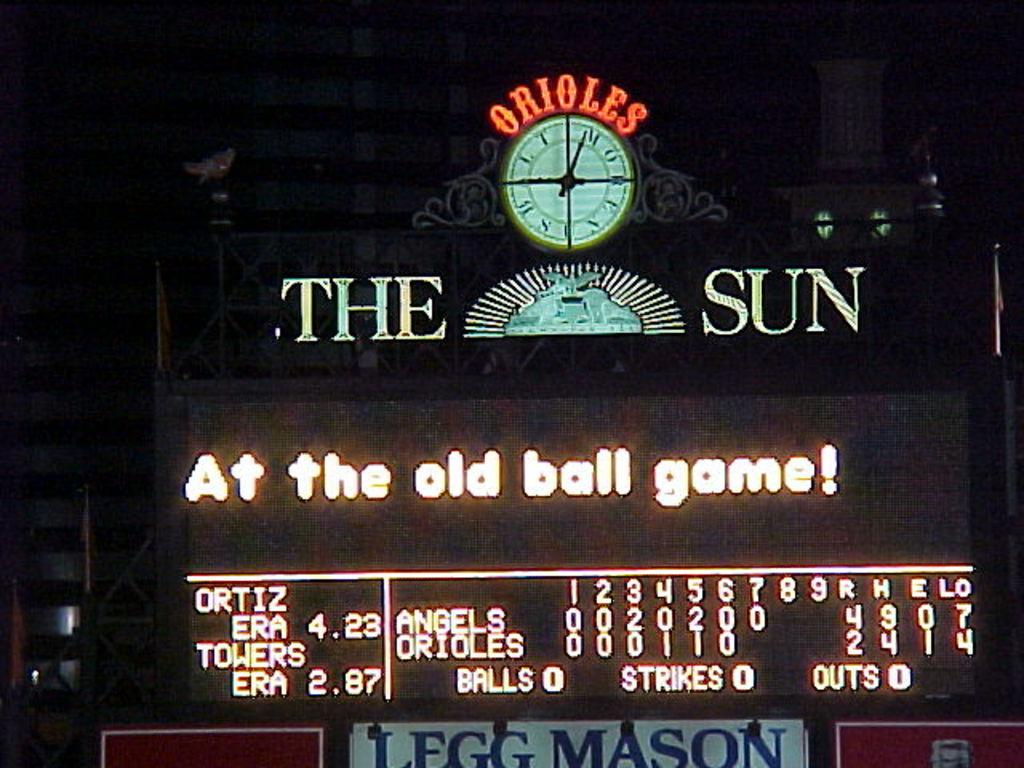<image>
Relay a brief, clear account of the picture shown. Scoreboard at a baseball game that says "At the old ball game!". 